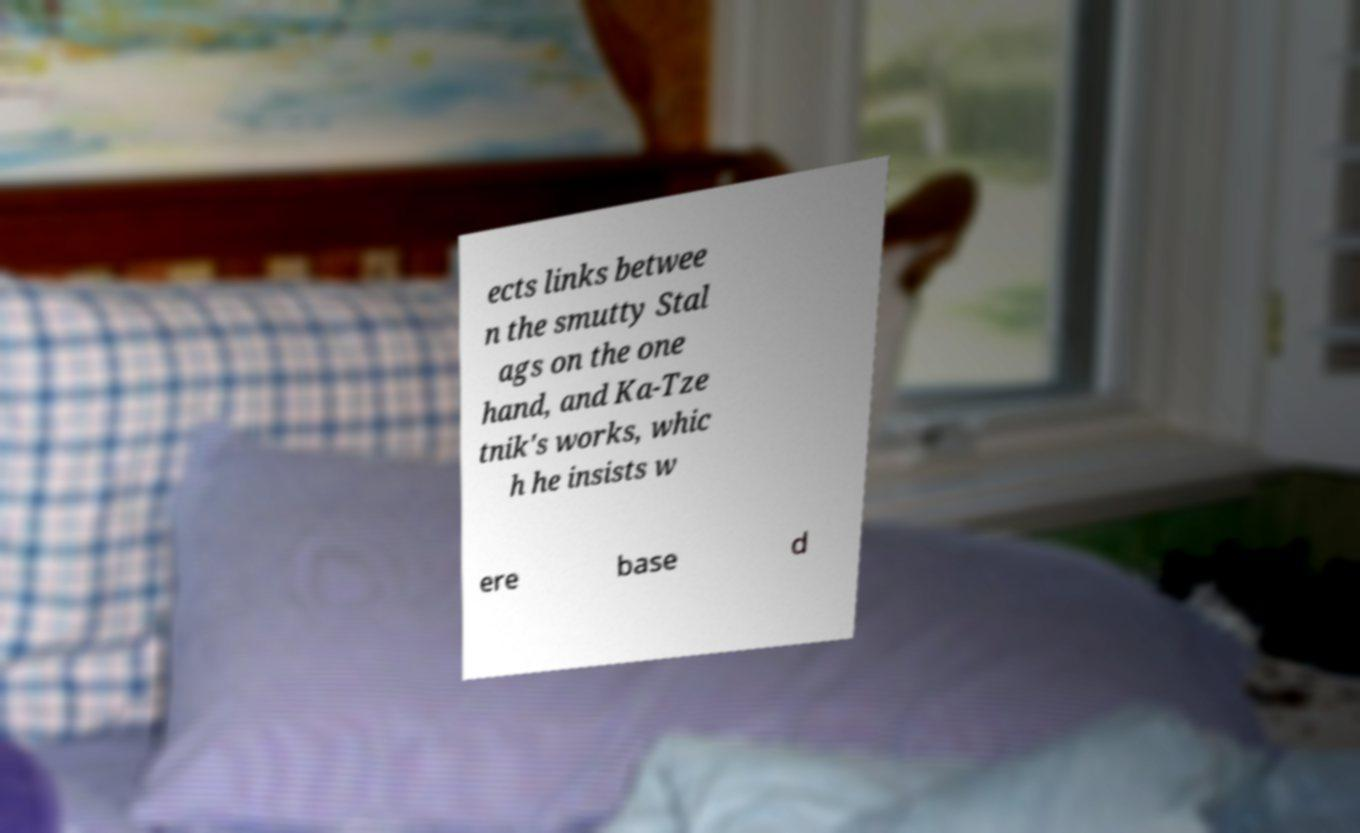Could you extract and type out the text from this image? ects links betwee n the smutty Stal ags on the one hand, and Ka-Tze tnik's works, whic h he insists w ere base d 